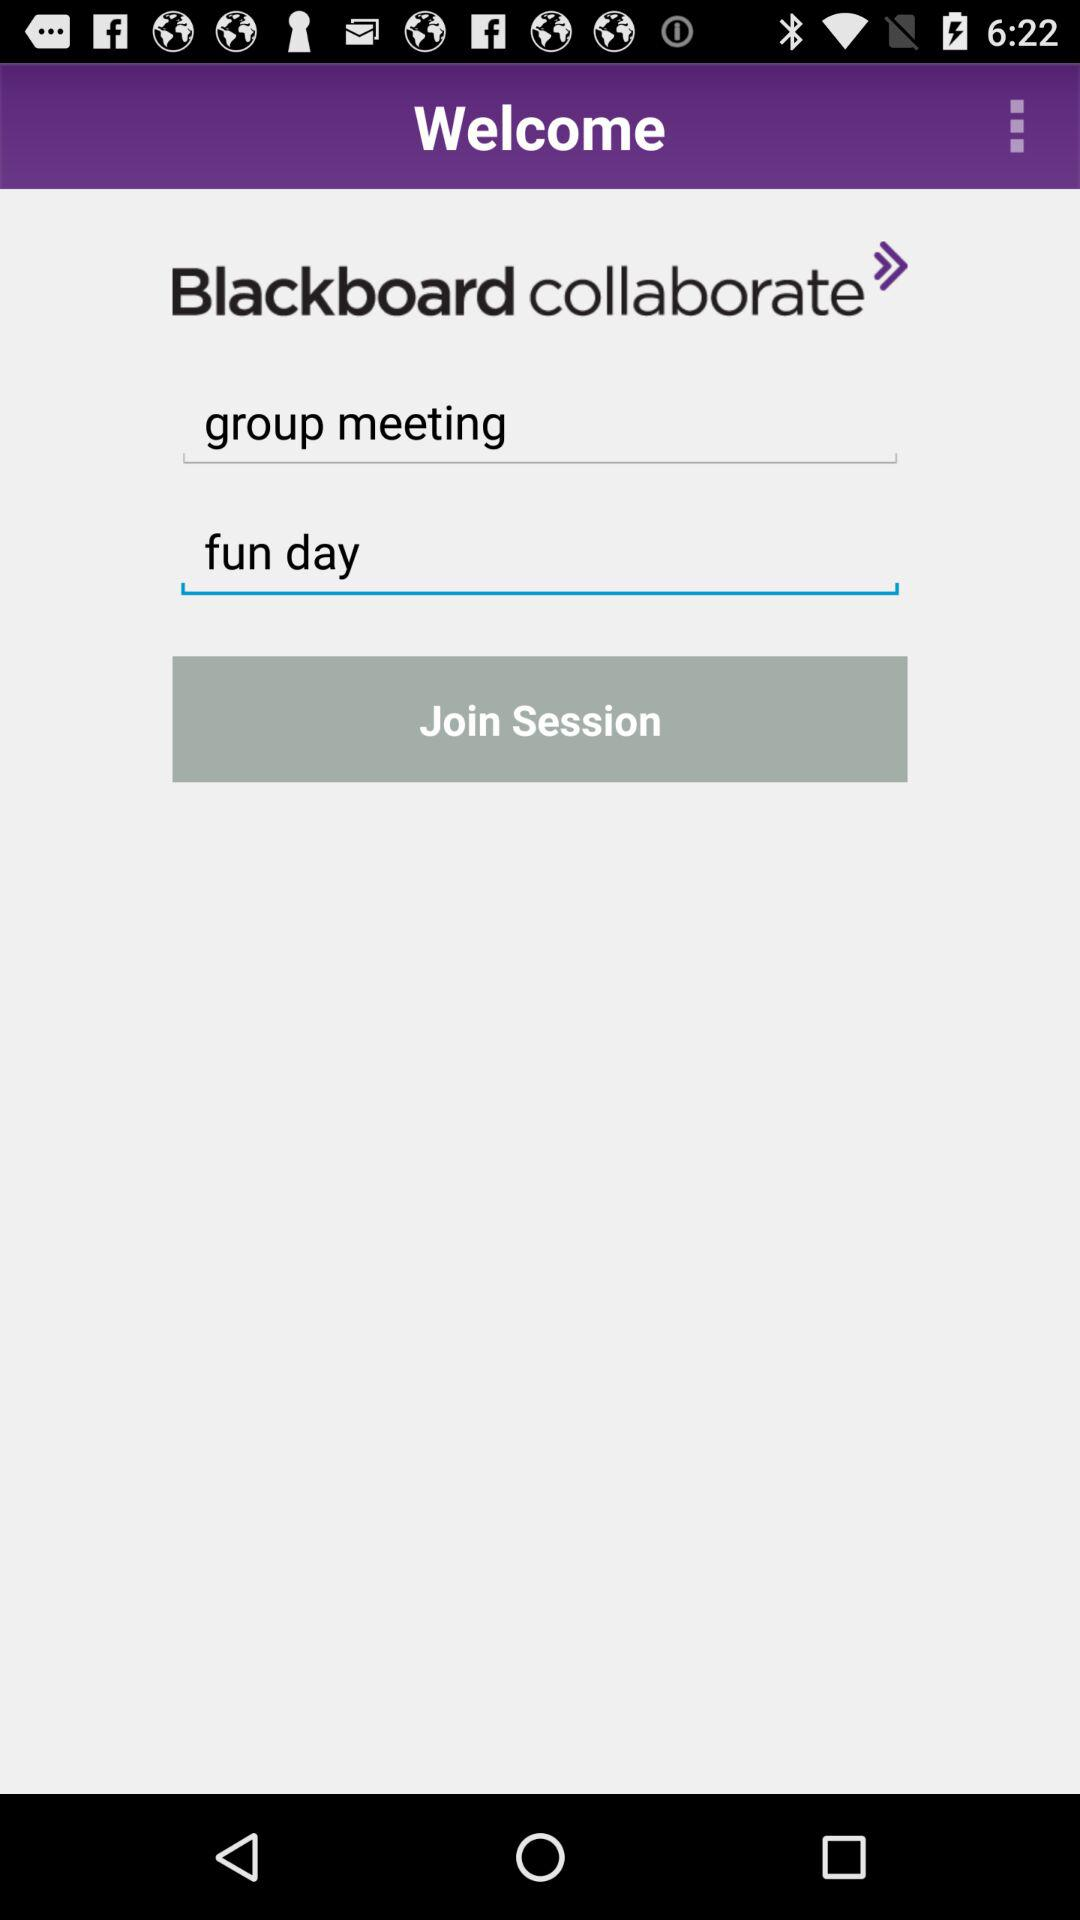What is the application name? The application name is "Blackboard collaborate". 